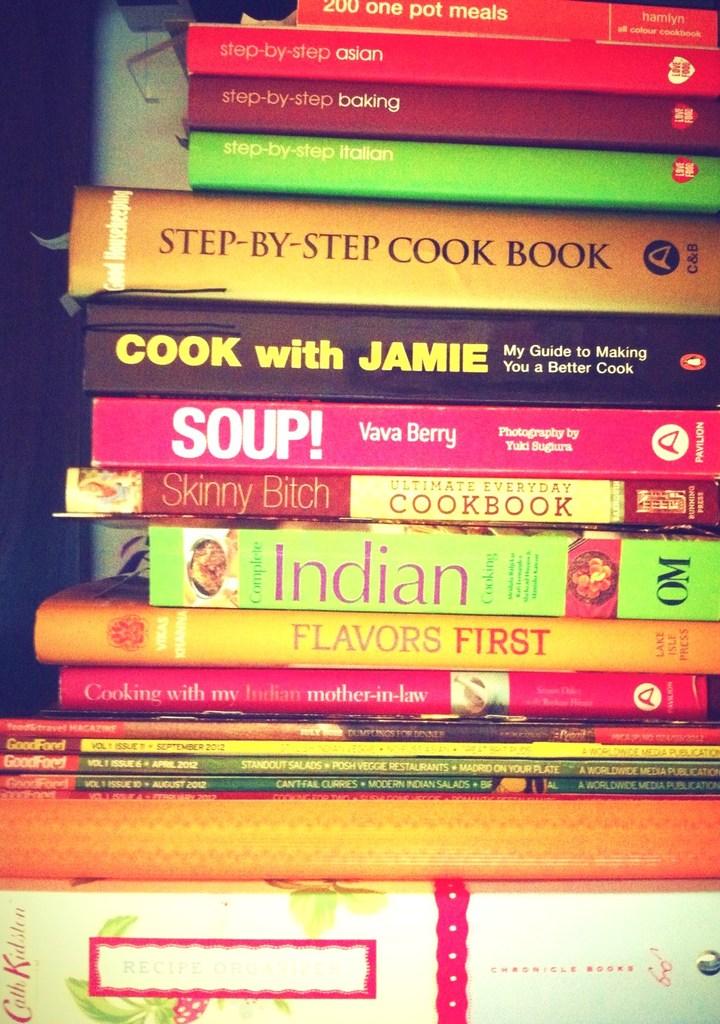What can these books teach me?
Make the answer very short. Cooking. Who wrote "soup!"?
Offer a terse response. Vava berry. 